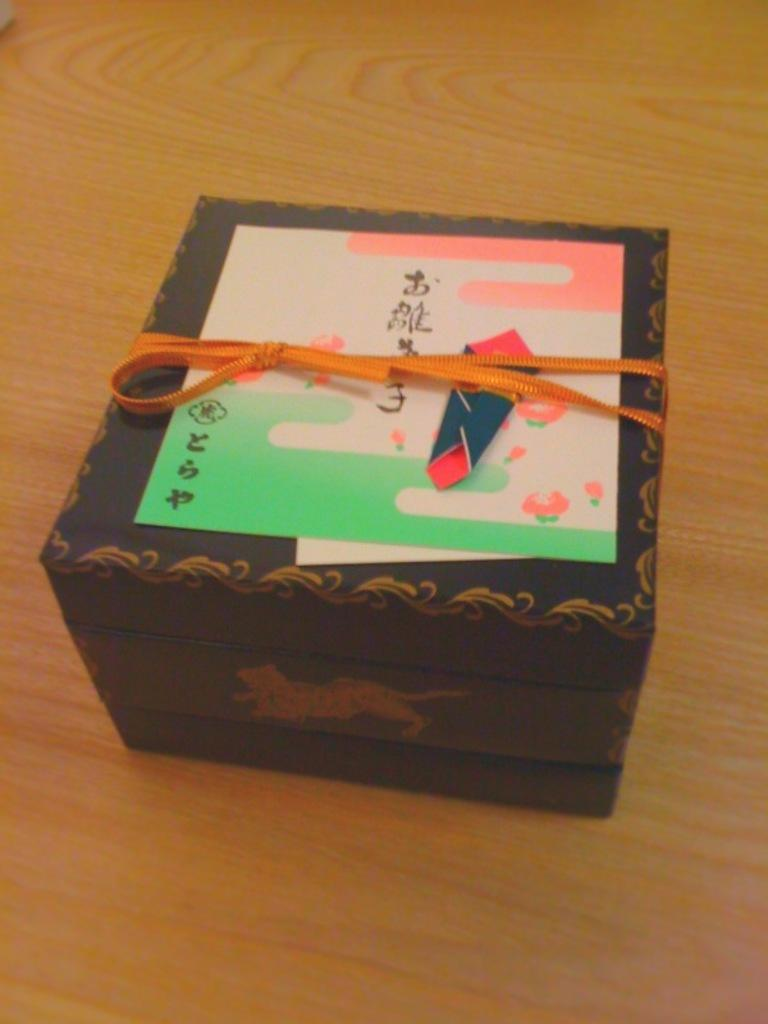<image>
Create a compact narrative representing the image presented. A wooden box has some foreign writing, but the bottom left corner looks like a flower with ESP printed under it. 